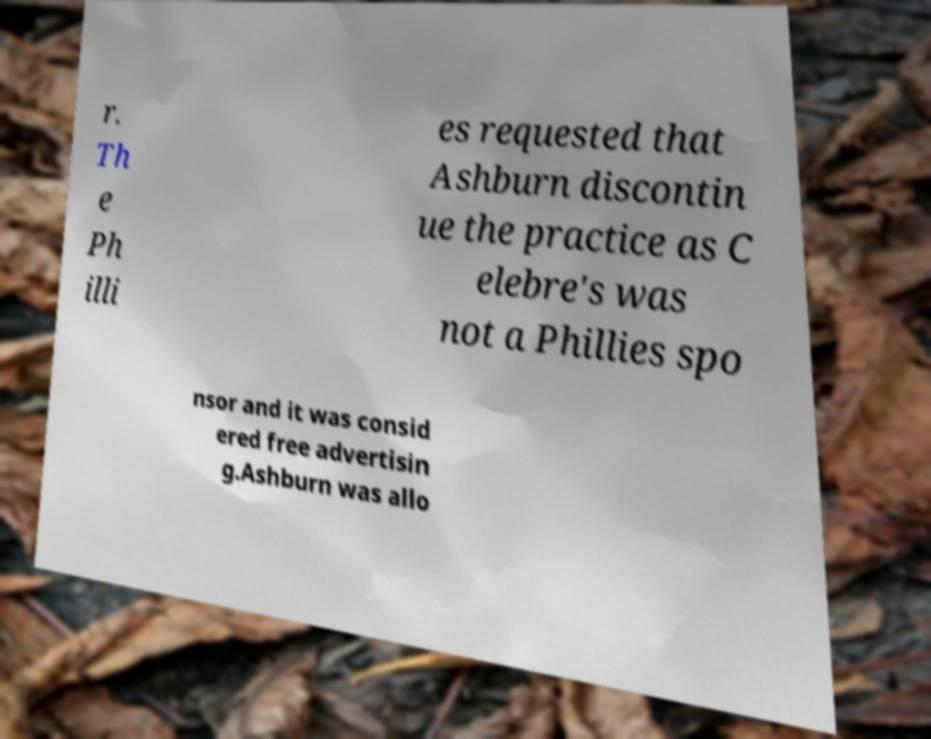I need the written content from this picture converted into text. Can you do that? r. Th e Ph illi es requested that Ashburn discontin ue the practice as C elebre's was not a Phillies spo nsor and it was consid ered free advertisin g.Ashburn was allo 